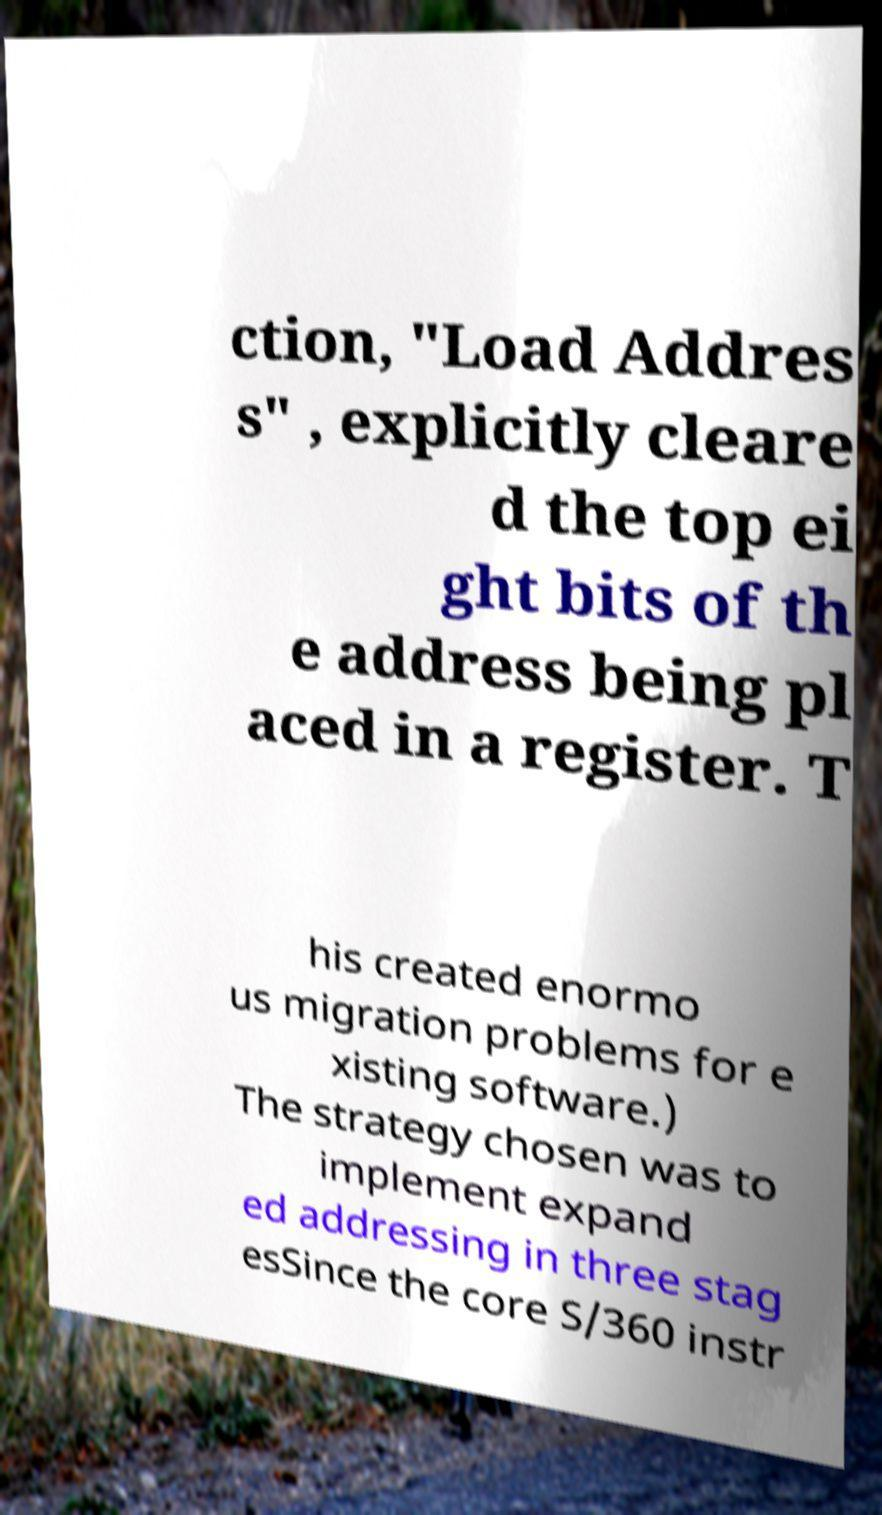Could you assist in decoding the text presented in this image and type it out clearly? ction, "Load Addres s" , explicitly cleare d the top ei ght bits of th e address being pl aced in a register. T his created enormo us migration problems for e xisting software.) The strategy chosen was to implement expand ed addressing in three stag esSince the core S/360 instr 